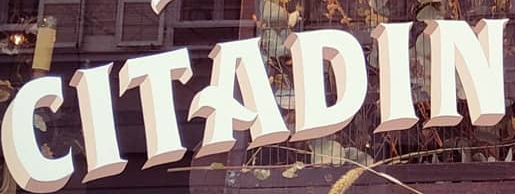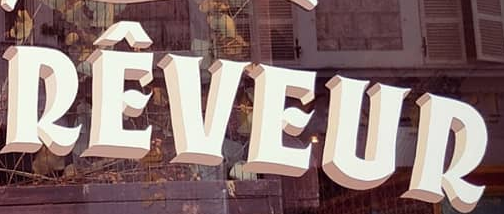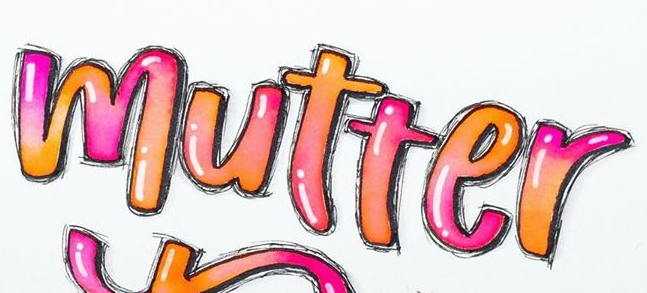Read the text from these images in sequence, separated by a semicolon. CITADIN; RÊVEUR; mutter 